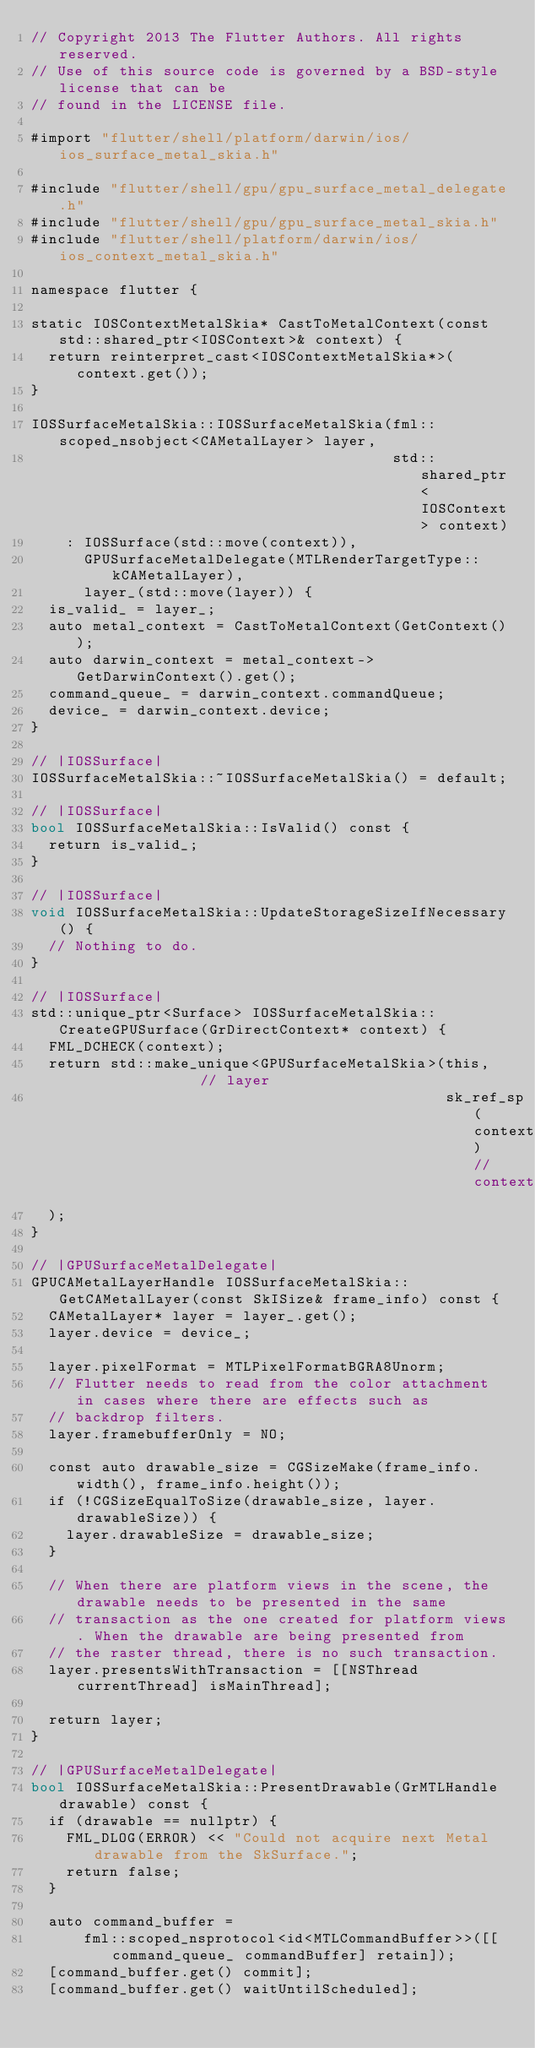Convert code to text. <code><loc_0><loc_0><loc_500><loc_500><_ObjectiveC_>// Copyright 2013 The Flutter Authors. All rights reserved.
// Use of this source code is governed by a BSD-style license that can be
// found in the LICENSE file.

#import "flutter/shell/platform/darwin/ios/ios_surface_metal_skia.h"

#include "flutter/shell/gpu/gpu_surface_metal_delegate.h"
#include "flutter/shell/gpu/gpu_surface_metal_skia.h"
#include "flutter/shell/platform/darwin/ios/ios_context_metal_skia.h"

namespace flutter {

static IOSContextMetalSkia* CastToMetalContext(const std::shared_ptr<IOSContext>& context) {
  return reinterpret_cast<IOSContextMetalSkia*>(context.get());
}

IOSSurfaceMetalSkia::IOSSurfaceMetalSkia(fml::scoped_nsobject<CAMetalLayer> layer,
                                         std::shared_ptr<IOSContext> context)
    : IOSSurface(std::move(context)),
      GPUSurfaceMetalDelegate(MTLRenderTargetType::kCAMetalLayer),
      layer_(std::move(layer)) {
  is_valid_ = layer_;
  auto metal_context = CastToMetalContext(GetContext());
  auto darwin_context = metal_context->GetDarwinContext().get();
  command_queue_ = darwin_context.commandQueue;
  device_ = darwin_context.device;
}

// |IOSSurface|
IOSSurfaceMetalSkia::~IOSSurfaceMetalSkia() = default;

// |IOSSurface|
bool IOSSurfaceMetalSkia::IsValid() const {
  return is_valid_;
}

// |IOSSurface|
void IOSSurfaceMetalSkia::UpdateStorageSizeIfNecessary() {
  // Nothing to do.
}

// |IOSSurface|
std::unique_ptr<Surface> IOSSurfaceMetalSkia::CreateGPUSurface(GrDirectContext* context) {
  FML_DCHECK(context);
  return std::make_unique<GPUSurfaceMetalSkia>(this,               // layer
                                               sk_ref_sp(context)  // context
  );
}

// |GPUSurfaceMetalDelegate|
GPUCAMetalLayerHandle IOSSurfaceMetalSkia::GetCAMetalLayer(const SkISize& frame_info) const {
  CAMetalLayer* layer = layer_.get();
  layer.device = device_;

  layer.pixelFormat = MTLPixelFormatBGRA8Unorm;
  // Flutter needs to read from the color attachment in cases where there are effects such as
  // backdrop filters.
  layer.framebufferOnly = NO;

  const auto drawable_size = CGSizeMake(frame_info.width(), frame_info.height());
  if (!CGSizeEqualToSize(drawable_size, layer.drawableSize)) {
    layer.drawableSize = drawable_size;
  }

  // When there are platform views in the scene, the drawable needs to be presented in the same
  // transaction as the one created for platform views. When the drawable are being presented from
  // the raster thread, there is no such transaction.
  layer.presentsWithTransaction = [[NSThread currentThread] isMainThread];

  return layer;
}

// |GPUSurfaceMetalDelegate|
bool IOSSurfaceMetalSkia::PresentDrawable(GrMTLHandle drawable) const {
  if (drawable == nullptr) {
    FML_DLOG(ERROR) << "Could not acquire next Metal drawable from the SkSurface.";
    return false;
  }

  auto command_buffer =
      fml::scoped_nsprotocol<id<MTLCommandBuffer>>([[command_queue_ commandBuffer] retain]);
  [command_buffer.get() commit];
  [command_buffer.get() waitUntilScheduled];
</code> 